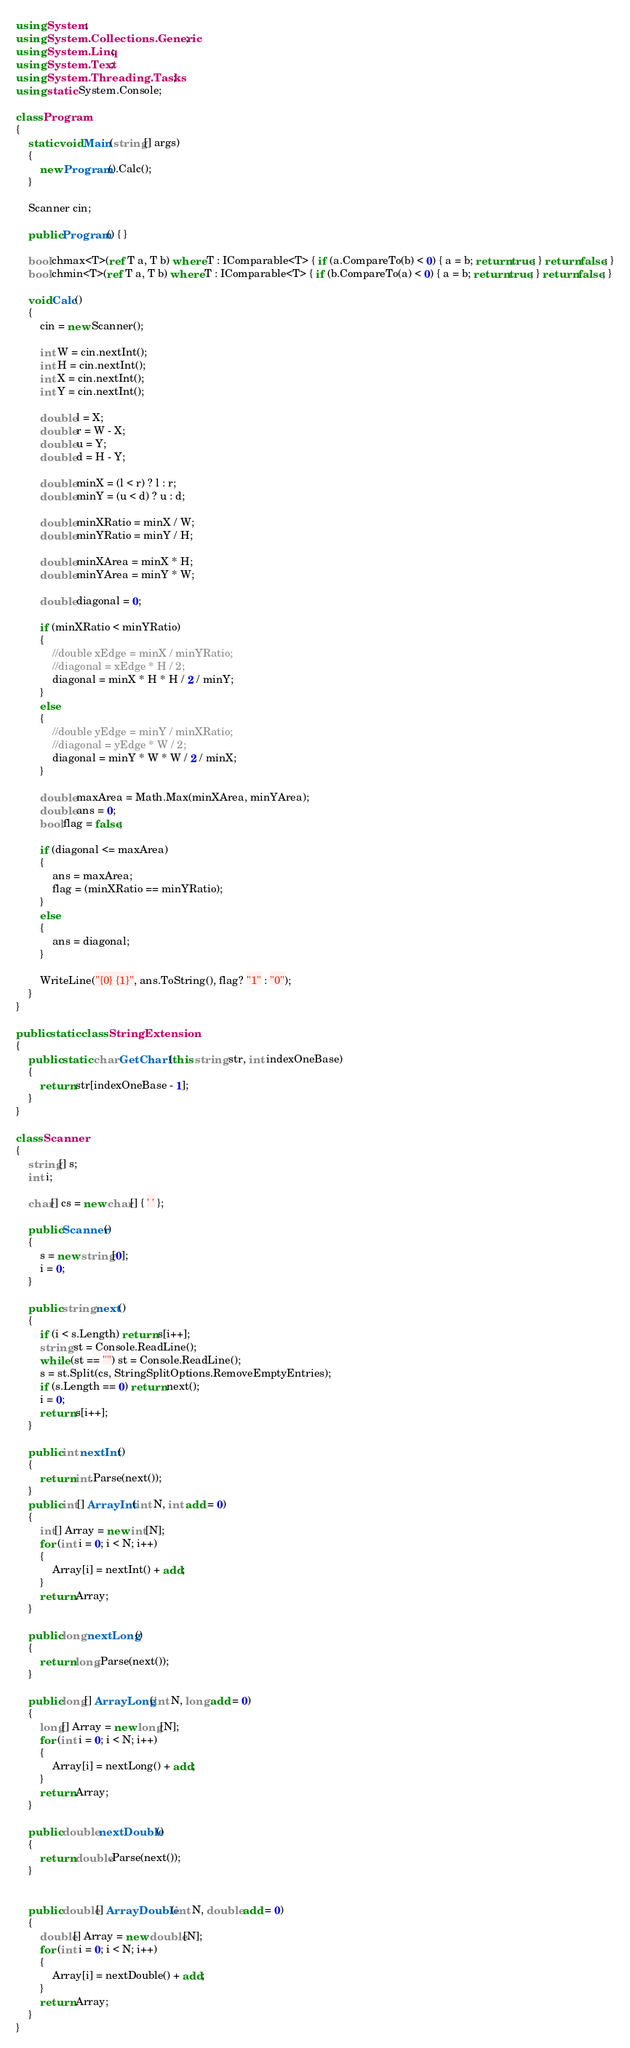<code> <loc_0><loc_0><loc_500><loc_500><_C#_>using System;
using System.Collections.Generic;
using System.Linq;
using System.Text;
using System.Threading.Tasks;
using static System.Console;

class Program
{
    static void Main(string[] args)
    {
        new Program().Calc();
    }

    Scanner cin;

    public Program() { }

    bool chmax<T>(ref T a, T b) where T : IComparable<T> { if (a.CompareTo(b) < 0) { a = b; return true; } return false; }
    bool chmin<T>(ref T a, T b) where T : IComparable<T> { if (b.CompareTo(a) < 0) { a = b; return true; } return false; }

    void Calc()
    {
        cin = new Scanner();

        int W = cin.nextInt();
        int H = cin.nextInt();
        int X = cin.nextInt();
        int Y = cin.nextInt();

        double l = X;
        double r = W - X;
        double u = Y;
        double d = H - Y;

        double minX = (l < r) ? l : r;
        double minY = (u < d) ? u : d;

        double minXRatio = minX / W;
        double minYRatio = minY / H;

        double minXArea = minX * H;
        double minYArea = minY * W;

        double diagonal = 0;

        if (minXRatio < minYRatio)
        {
            //double xEdge = minX / minYRatio;
            //diagonal = xEdge * H / 2;
            diagonal = minX * H * H / 2 / minY;
        }
        else
        {
            //double yEdge = minY / minXRatio;
            //diagonal = yEdge * W / 2;
            diagonal = minY * W * W / 2 / minX;
        }

        double maxArea = Math.Max(minXArea, minYArea);
        double ans = 0;
        bool flag = false;

        if (diagonal <= maxArea)
        {
            ans = maxArea;
            flag = (minXRatio == minYRatio);
        }
        else
        {
            ans = diagonal;
        }

        WriteLine("{0} {1}", ans.ToString(), flag? "1" : "0");
    }
}

public static class StringExtension
{
    public static char GetChar1(this string str, int indexOneBase)
    {
        return str[indexOneBase - 1];
    }
}

class Scanner
{
    string[] s;
    int i;

    char[] cs = new char[] { ' ' };

    public Scanner()
    {
        s = new string[0];
        i = 0;
    }

    public string next()
    {
        if (i < s.Length) return s[i++];
        string st = Console.ReadLine();
        while (st == "") st = Console.ReadLine();
        s = st.Split(cs, StringSplitOptions.RemoveEmptyEntries);
        if (s.Length == 0) return next();
        i = 0;
        return s[i++];
    }

    public int nextInt()
    {
        return int.Parse(next());
    }
    public int[] ArrayInt(int N, int add = 0)
    {
        int[] Array = new int[N];
        for (int i = 0; i < N; i++)
        {
            Array[i] = nextInt() + add;
        }
        return Array;
    }

    public long nextLong()
    {
        return long.Parse(next());
    }

    public long[] ArrayLong(int N, long add = 0)
    {
        long[] Array = new long[N];
        for (int i = 0; i < N; i++)
        {
            Array[i] = nextLong() + add;
        }
        return Array;
    }

    public double nextDouble()
    {
        return double.Parse(next());
    }


    public double[] ArrayDouble(int N, double add = 0)
    {
        double[] Array = new double[N];
        for (int i = 0; i < N; i++)
        {
            Array[i] = nextDouble() + add;
        }
        return Array;
    }
}
</code> 